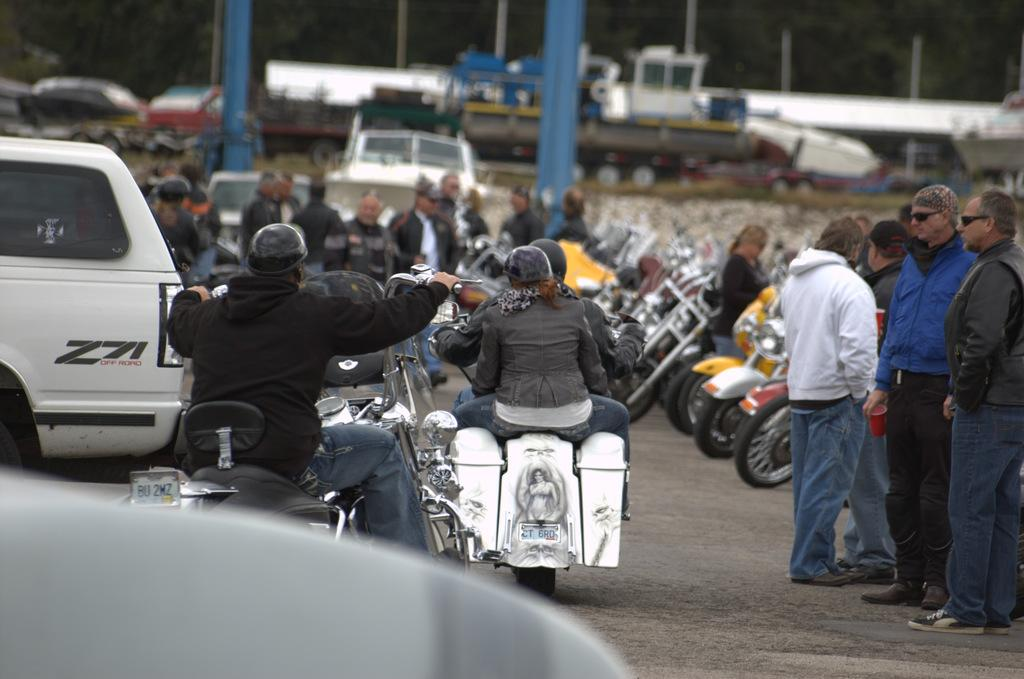What are the people in the image doing? There are people standing and riding a vehicle in the image. Can you describe the vehicles in the image? There are vehicles parked on the inside of the road in the image. What type of music can be heard coming from the bit in the image? There is no bit or music present in the image. 